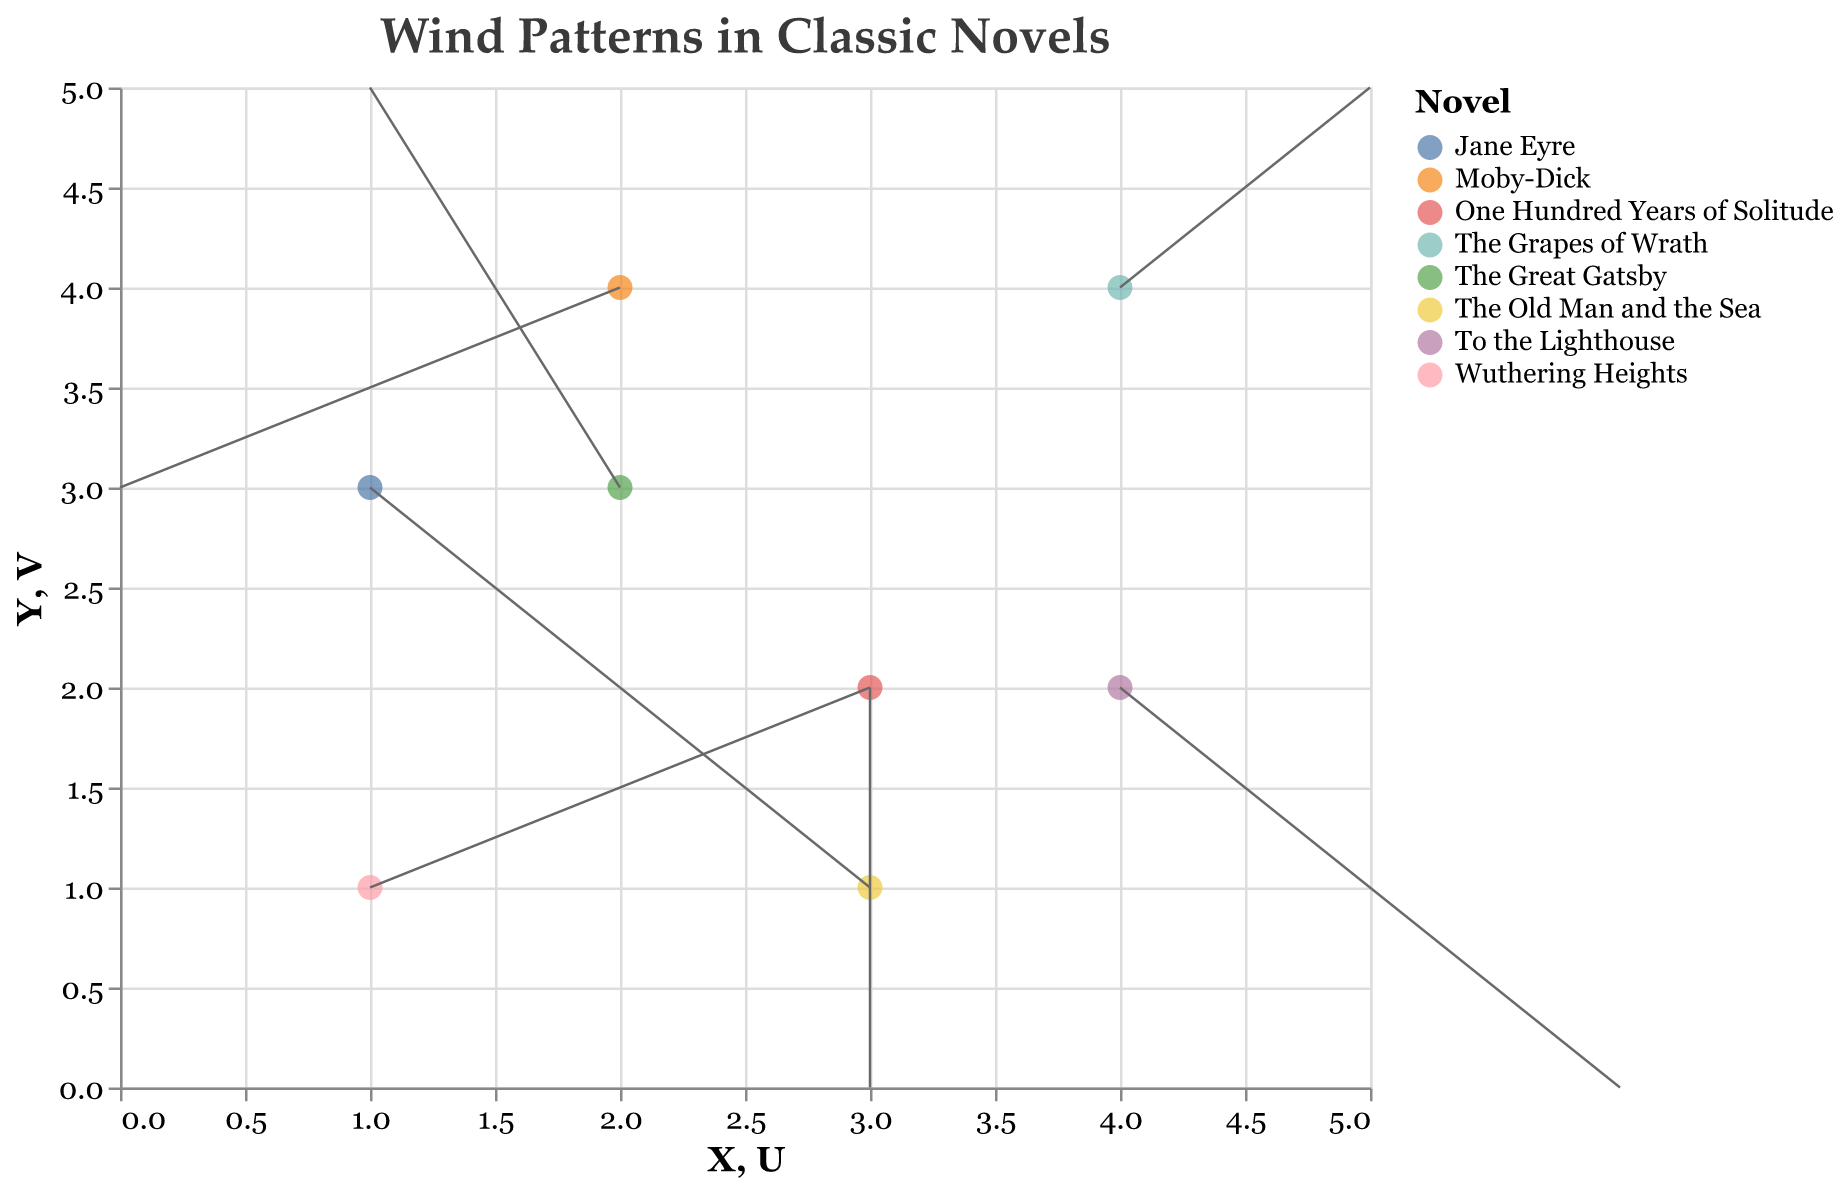what is the title of the figure? The title is usually placed at the top of the figure. It describes the main purpose or topic of the visual. Here, the title indicates the focus on wind patterns in classic novels.
Answer: Wind Patterns in Classic Novels Which novel is characterized by "Dust Bowl winds"? Look for the tooltip or legend and locate the novel associated with "Dust Bowl winds." It is marked at coordinates (4, 4).
Answer: The Grapes of Wrath How does the wind influence in "The Old Man and the Sea" compare to "Moby-Dick"? Locate both novels in the plot, indicated by their positions and wind vectors. Observe the direction and length of the arrows for both to understand their influence.
Answer: "The Old Man and the Sea" has Caribbean trade winds, while "Moby-Dick" has open ocean trade winds What is the general wind direction in "One Hundred Years of Solitude"? Look at the wind vector starting at (3, 2) and see where the arrow points. The vector indicates the direction and strength of the wind influence.
Answer: Tropical storm patterns (downward, southward) Which novel experiences the most significant wind from the east? Observe all wind vectors and identify the one with the most substantial movement towards the left on the plot (positive x-component).
Answer: Wuthering Heights What is the wind pattern in "Jane Eyre"? Find the novel in the plot (coordinate 1, 3). The vector direction and magnitude will indicate the wind pattern around the character.
Answer: Moorland gusts Which novel has the strongest wind pattern based on the length of the vectors? Compare the lengths of all the vectors (arrows) to see which one is the longest, indicating the strongest wind pattern.
Answer: Wuthering Heights Between "The Grapes of Wrath" and "To the Lighthouse," which has a stronger perpendicular component? Look at the vertical (V) components of the vectors for both novels. "The Grapes of Wrath" is at (4, 4) and "To the Lighthouse" at (4, 2). Compare their magnitudes.
Answer: To the Lighthouse What unifying theme can you infer from the wind patterns in these novels? Analyze how varied wind influences reflect the atmosphere, setting, and context of each novel. Wind patterns often align with the emotional landscape and geographical setting of the literature.
Answer: Environment and mood shaping in the setting and context of the novels 